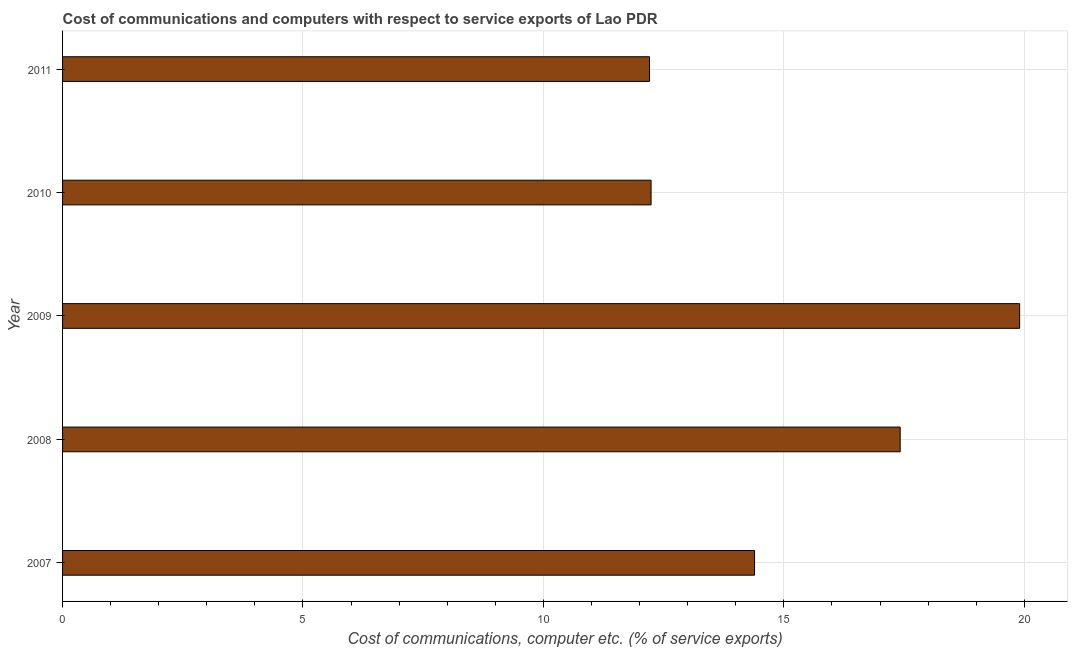Does the graph contain any zero values?
Your answer should be compact. No. What is the title of the graph?
Provide a succinct answer. Cost of communications and computers with respect to service exports of Lao PDR. What is the label or title of the X-axis?
Give a very brief answer. Cost of communications, computer etc. (% of service exports). What is the label or title of the Y-axis?
Your response must be concise. Year. What is the cost of communications and computer in 2008?
Make the answer very short. 17.42. Across all years, what is the maximum cost of communications and computer?
Your answer should be very brief. 19.9. Across all years, what is the minimum cost of communications and computer?
Keep it short and to the point. 12.21. In which year was the cost of communications and computer maximum?
Your answer should be compact. 2009. What is the sum of the cost of communications and computer?
Offer a very short reply. 76.16. What is the difference between the cost of communications and computer in 2008 and 2010?
Offer a terse response. 5.18. What is the average cost of communications and computer per year?
Your answer should be very brief. 15.23. What is the median cost of communications and computer?
Give a very brief answer. 14.39. What is the ratio of the cost of communications and computer in 2008 to that in 2011?
Ensure brevity in your answer.  1.43. Is the difference between the cost of communications and computer in 2008 and 2011 greater than the difference between any two years?
Your answer should be compact. No. What is the difference between the highest and the second highest cost of communications and computer?
Make the answer very short. 2.48. Is the sum of the cost of communications and computer in 2007 and 2011 greater than the maximum cost of communications and computer across all years?
Offer a terse response. Yes. What is the difference between the highest and the lowest cost of communications and computer?
Provide a succinct answer. 7.7. How many bars are there?
Give a very brief answer. 5. Are all the bars in the graph horizontal?
Offer a terse response. Yes. How many years are there in the graph?
Your answer should be compact. 5. Are the values on the major ticks of X-axis written in scientific E-notation?
Offer a very short reply. No. What is the Cost of communications, computer etc. (% of service exports) of 2007?
Give a very brief answer. 14.39. What is the Cost of communications, computer etc. (% of service exports) of 2008?
Provide a short and direct response. 17.42. What is the Cost of communications, computer etc. (% of service exports) in 2009?
Offer a very short reply. 19.9. What is the Cost of communications, computer etc. (% of service exports) of 2010?
Give a very brief answer. 12.24. What is the Cost of communications, computer etc. (% of service exports) of 2011?
Provide a short and direct response. 12.21. What is the difference between the Cost of communications, computer etc. (% of service exports) in 2007 and 2008?
Give a very brief answer. -3.03. What is the difference between the Cost of communications, computer etc. (% of service exports) in 2007 and 2009?
Offer a terse response. -5.51. What is the difference between the Cost of communications, computer etc. (% of service exports) in 2007 and 2010?
Ensure brevity in your answer.  2.15. What is the difference between the Cost of communications, computer etc. (% of service exports) in 2007 and 2011?
Ensure brevity in your answer.  2.18. What is the difference between the Cost of communications, computer etc. (% of service exports) in 2008 and 2009?
Make the answer very short. -2.48. What is the difference between the Cost of communications, computer etc. (% of service exports) in 2008 and 2010?
Keep it short and to the point. 5.18. What is the difference between the Cost of communications, computer etc. (% of service exports) in 2008 and 2011?
Your answer should be compact. 5.21. What is the difference between the Cost of communications, computer etc. (% of service exports) in 2009 and 2010?
Your response must be concise. 7.67. What is the difference between the Cost of communications, computer etc. (% of service exports) in 2009 and 2011?
Your answer should be very brief. 7.7. What is the difference between the Cost of communications, computer etc. (% of service exports) in 2010 and 2011?
Your answer should be very brief. 0.03. What is the ratio of the Cost of communications, computer etc. (% of service exports) in 2007 to that in 2008?
Your response must be concise. 0.83. What is the ratio of the Cost of communications, computer etc. (% of service exports) in 2007 to that in 2009?
Offer a terse response. 0.72. What is the ratio of the Cost of communications, computer etc. (% of service exports) in 2007 to that in 2010?
Keep it short and to the point. 1.18. What is the ratio of the Cost of communications, computer etc. (% of service exports) in 2007 to that in 2011?
Offer a terse response. 1.18. What is the ratio of the Cost of communications, computer etc. (% of service exports) in 2008 to that in 2009?
Your answer should be compact. 0.88. What is the ratio of the Cost of communications, computer etc. (% of service exports) in 2008 to that in 2010?
Offer a very short reply. 1.42. What is the ratio of the Cost of communications, computer etc. (% of service exports) in 2008 to that in 2011?
Make the answer very short. 1.43. What is the ratio of the Cost of communications, computer etc. (% of service exports) in 2009 to that in 2010?
Give a very brief answer. 1.63. What is the ratio of the Cost of communications, computer etc. (% of service exports) in 2009 to that in 2011?
Ensure brevity in your answer.  1.63. What is the ratio of the Cost of communications, computer etc. (% of service exports) in 2010 to that in 2011?
Offer a very short reply. 1. 